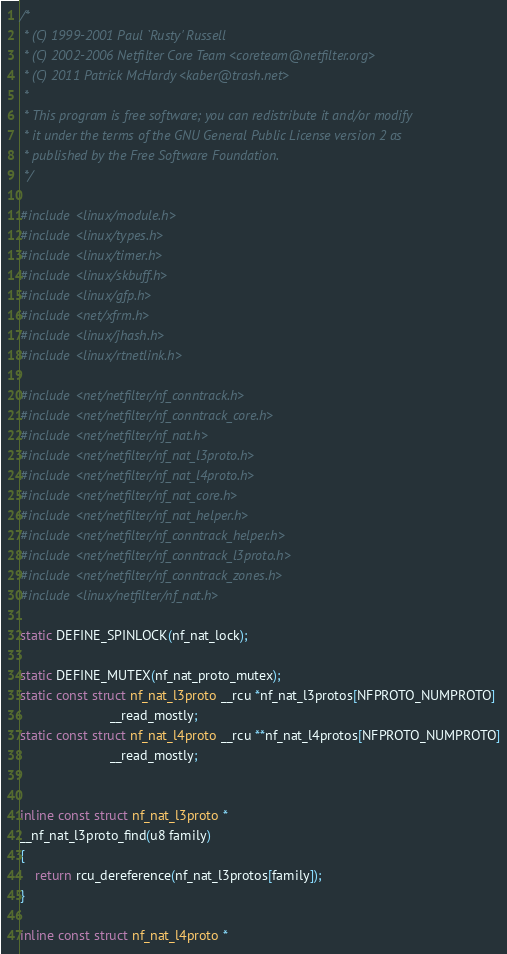<code> <loc_0><loc_0><loc_500><loc_500><_C_>/*
 * (C) 1999-2001 Paul `Rusty' Russell
 * (C) 2002-2006 Netfilter Core Team <coreteam@netfilter.org>
 * (C) 2011 Patrick McHardy <kaber@trash.net>
 *
 * This program is free software; you can redistribute it and/or modify
 * it under the terms of the GNU General Public License version 2 as
 * published by the Free Software Foundation.
 */

#include <linux/module.h>
#include <linux/types.h>
#include <linux/timer.h>
#include <linux/skbuff.h>
#include <linux/gfp.h>
#include <net/xfrm.h>
#include <linux/jhash.h>
#include <linux/rtnetlink.h>

#include <net/netfilter/nf_conntrack.h>
#include <net/netfilter/nf_conntrack_core.h>
#include <net/netfilter/nf_nat.h>
#include <net/netfilter/nf_nat_l3proto.h>
#include <net/netfilter/nf_nat_l4proto.h>
#include <net/netfilter/nf_nat_core.h>
#include <net/netfilter/nf_nat_helper.h>
#include <net/netfilter/nf_conntrack_helper.h>
#include <net/netfilter/nf_conntrack_l3proto.h>
#include <net/netfilter/nf_conntrack_zones.h>
#include <linux/netfilter/nf_nat.h>

static DEFINE_SPINLOCK(nf_nat_lock);

static DEFINE_MUTEX(nf_nat_proto_mutex);
static const struct nf_nat_l3proto __rcu *nf_nat_l3protos[NFPROTO_NUMPROTO]
						__read_mostly;
static const struct nf_nat_l4proto __rcu **nf_nat_l4protos[NFPROTO_NUMPROTO]
						__read_mostly;


inline const struct nf_nat_l3proto *
__nf_nat_l3proto_find(u8 family)
{
	return rcu_dereference(nf_nat_l3protos[family]);
}

inline const struct nf_nat_l4proto *</code> 